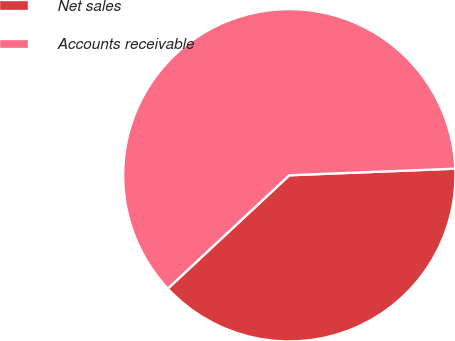<chart> <loc_0><loc_0><loc_500><loc_500><pie_chart><fcel>Net sales<fcel>Accounts receivable<nl><fcel>38.69%<fcel>61.31%<nl></chart> 